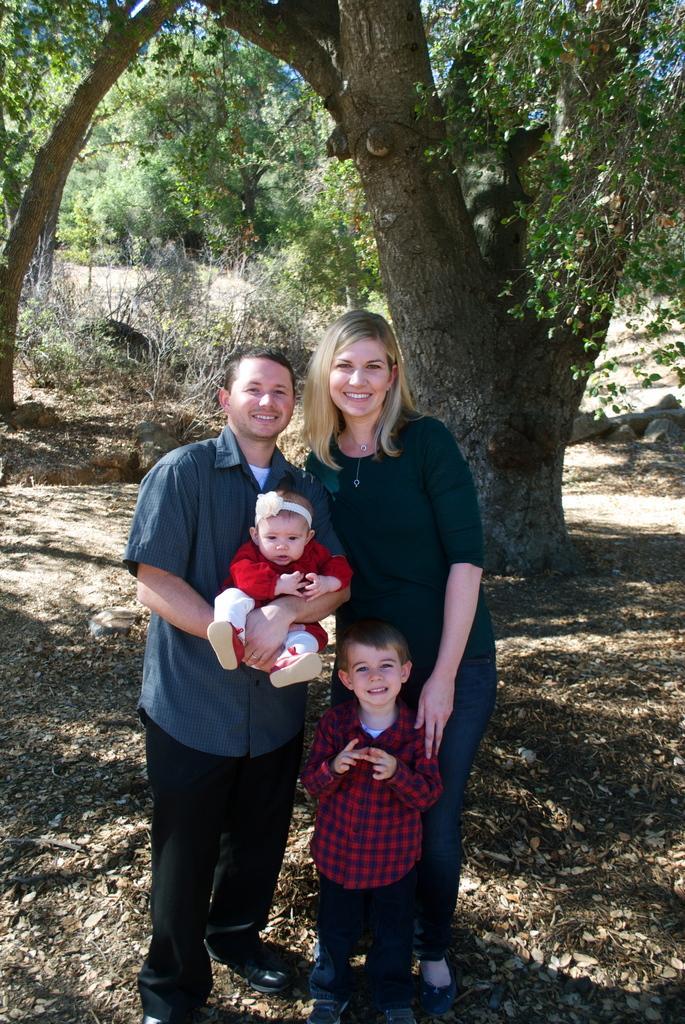Could you give a brief overview of what you see in this image? In this image I can see three persons standing. The person at left is holding the baby. In the background I can see few trees in green color and the sky is in blue color. 